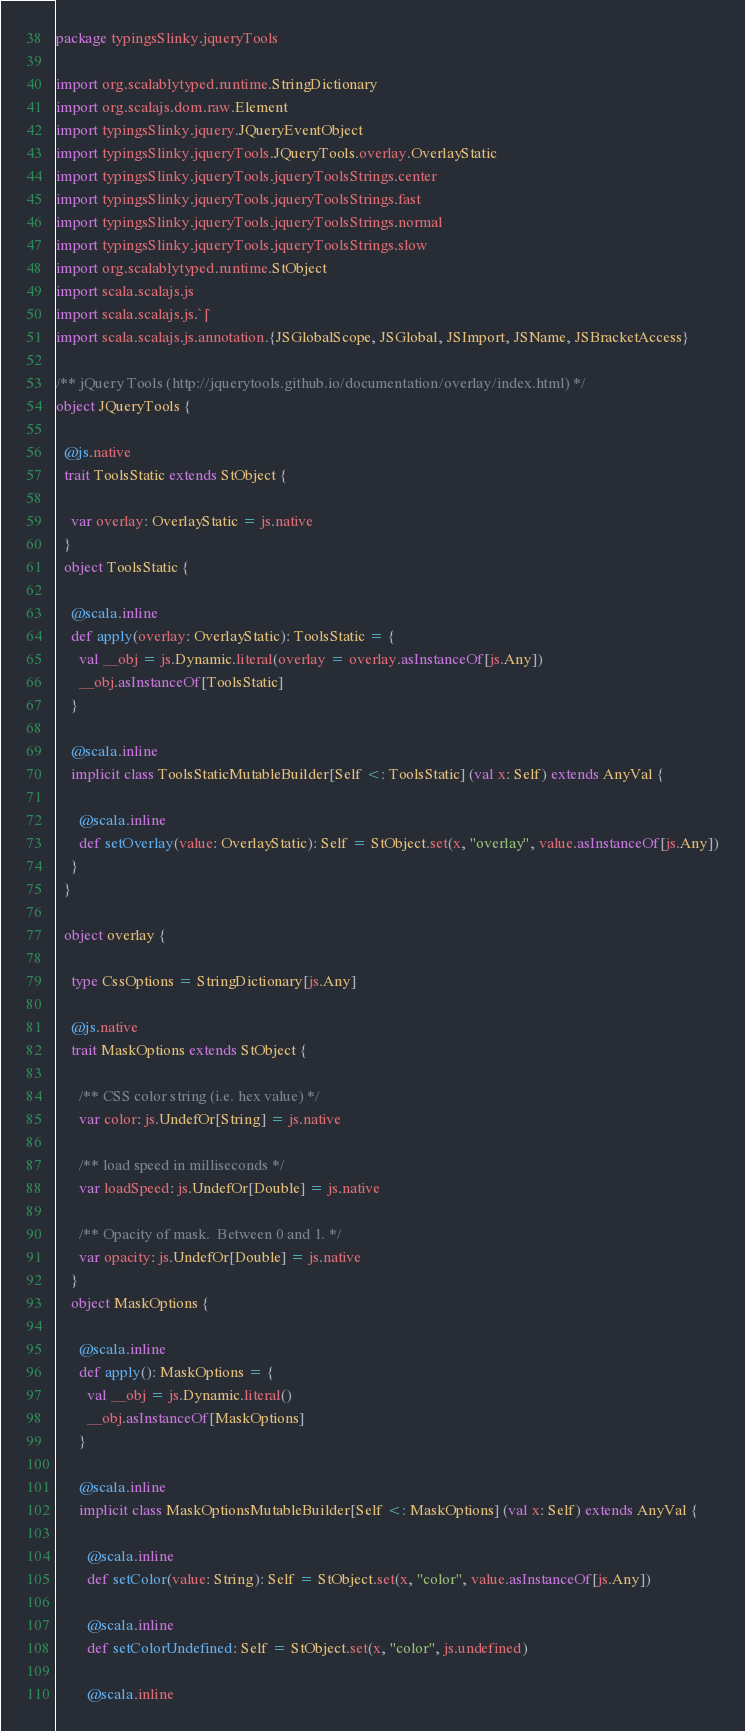Convert code to text. <code><loc_0><loc_0><loc_500><loc_500><_Scala_>package typingsSlinky.jqueryTools

import org.scalablytyped.runtime.StringDictionary
import org.scalajs.dom.raw.Element
import typingsSlinky.jquery.JQueryEventObject
import typingsSlinky.jqueryTools.JQueryTools.overlay.OverlayStatic
import typingsSlinky.jqueryTools.jqueryToolsStrings.center
import typingsSlinky.jqueryTools.jqueryToolsStrings.fast
import typingsSlinky.jqueryTools.jqueryToolsStrings.normal
import typingsSlinky.jqueryTools.jqueryToolsStrings.slow
import org.scalablytyped.runtime.StObject
import scala.scalajs.js
import scala.scalajs.js.`|`
import scala.scalajs.js.annotation.{JSGlobalScope, JSGlobal, JSImport, JSName, JSBracketAccess}

/** jQuery Tools (http://jquerytools.github.io/documentation/overlay/index.html) */
object JQueryTools {
  
  @js.native
  trait ToolsStatic extends StObject {
    
    var overlay: OverlayStatic = js.native
  }
  object ToolsStatic {
    
    @scala.inline
    def apply(overlay: OverlayStatic): ToolsStatic = {
      val __obj = js.Dynamic.literal(overlay = overlay.asInstanceOf[js.Any])
      __obj.asInstanceOf[ToolsStatic]
    }
    
    @scala.inline
    implicit class ToolsStaticMutableBuilder[Self <: ToolsStatic] (val x: Self) extends AnyVal {
      
      @scala.inline
      def setOverlay(value: OverlayStatic): Self = StObject.set(x, "overlay", value.asInstanceOf[js.Any])
    }
  }
  
  object overlay {
    
    type CssOptions = StringDictionary[js.Any]
    
    @js.native
    trait MaskOptions extends StObject {
      
      /** CSS color string (i.e. hex value) */
      var color: js.UndefOr[String] = js.native
      
      /** load speed in milliseconds */
      var loadSpeed: js.UndefOr[Double] = js.native
      
      /** Opacity of mask.  Between 0 and 1. */
      var opacity: js.UndefOr[Double] = js.native
    }
    object MaskOptions {
      
      @scala.inline
      def apply(): MaskOptions = {
        val __obj = js.Dynamic.literal()
        __obj.asInstanceOf[MaskOptions]
      }
      
      @scala.inline
      implicit class MaskOptionsMutableBuilder[Self <: MaskOptions] (val x: Self) extends AnyVal {
        
        @scala.inline
        def setColor(value: String): Self = StObject.set(x, "color", value.asInstanceOf[js.Any])
        
        @scala.inline
        def setColorUndefined: Self = StObject.set(x, "color", js.undefined)
        
        @scala.inline</code> 